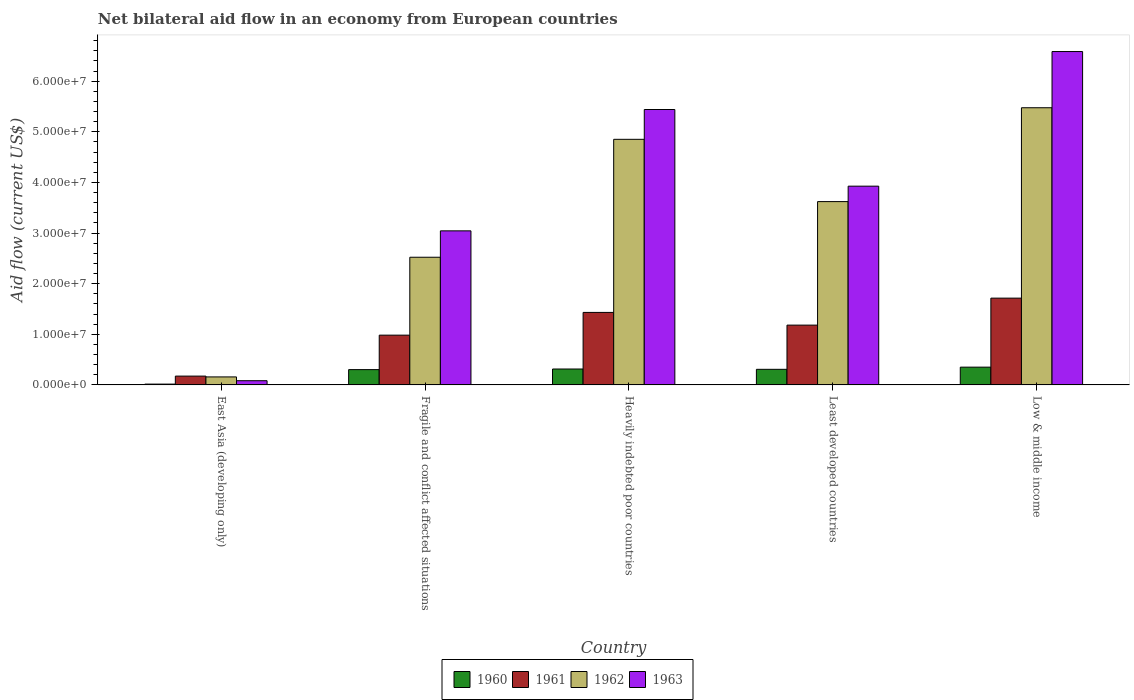How many different coloured bars are there?
Give a very brief answer. 4. How many groups of bars are there?
Your response must be concise. 5. Are the number of bars per tick equal to the number of legend labels?
Make the answer very short. Yes. What is the label of the 4th group of bars from the left?
Offer a terse response. Least developed countries. What is the net bilateral aid flow in 1962 in Least developed countries?
Make the answer very short. 3.62e+07. Across all countries, what is the maximum net bilateral aid flow in 1961?
Ensure brevity in your answer.  1.71e+07. Across all countries, what is the minimum net bilateral aid flow in 1961?
Your answer should be compact. 1.74e+06. In which country was the net bilateral aid flow in 1963 maximum?
Give a very brief answer. Low & middle income. In which country was the net bilateral aid flow in 1962 minimum?
Offer a very short reply. East Asia (developing only). What is the total net bilateral aid flow in 1963 in the graph?
Your response must be concise. 1.91e+08. What is the difference between the net bilateral aid flow in 1962 in Fragile and conflict affected situations and that in Heavily indebted poor countries?
Provide a succinct answer. -2.33e+07. What is the difference between the net bilateral aid flow in 1963 in East Asia (developing only) and the net bilateral aid flow in 1961 in Least developed countries?
Provide a succinct answer. -1.10e+07. What is the average net bilateral aid flow in 1963 per country?
Provide a short and direct response. 3.82e+07. What is the difference between the net bilateral aid flow of/in 1960 and net bilateral aid flow of/in 1963 in Least developed countries?
Provide a short and direct response. -3.62e+07. What is the ratio of the net bilateral aid flow in 1960 in Least developed countries to that in Low & middle income?
Give a very brief answer. 0.88. What is the difference between the highest and the second highest net bilateral aid flow in 1960?
Provide a succinct answer. 4.30e+05. What is the difference between the highest and the lowest net bilateral aid flow in 1962?
Ensure brevity in your answer.  5.32e+07. Is the sum of the net bilateral aid flow in 1961 in Least developed countries and Low & middle income greater than the maximum net bilateral aid flow in 1963 across all countries?
Make the answer very short. No. Is it the case that in every country, the sum of the net bilateral aid flow in 1960 and net bilateral aid flow in 1962 is greater than the sum of net bilateral aid flow in 1961 and net bilateral aid flow in 1963?
Provide a succinct answer. No. What does the 3rd bar from the left in Fragile and conflict affected situations represents?
Your answer should be very brief. 1962. How many bars are there?
Provide a short and direct response. 20. Are the values on the major ticks of Y-axis written in scientific E-notation?
Provide a short and direct response. Yes. Where does the legend appear in the graph?
Your answer should be very brief. Bottom center. What is the title of the graph?
Your response must be concise. Net bilateral aid flow in an economy from European countries. Does "2001" appear as one of the legend labels in the graph?
Offer a very short reply. No. What is the label or title of the Y-axis?
Offer a very short reply. Aid flow (current US$). What is the Aid flow (current US$) in 1961 in East Asia (developing only)?
Your answer should be compact. 1.74e+06. What is the Aid flow (current US$) of 1962 in East Asia (developing only)?
Give a very brief answer. 1.58e+06. What is the Aid flow (current US$) in 1963 in East Asia (developing only)?
Make the answer very short. 8.30e+05. What is the Aid flow (current US$) in 1960 in Fragile and conflict affected situations?
Give a very brief answer. 3.02e+06. What is the Aid flow (current US$) in 1961 in Fragile and conflict affected situations?
Give a very brief answer. 9.83e+06. What is the Aid flow (current US$) in 1962 in Fragile and conflict affected situations?
Ensure brevity in your answer.  2.52e+07. What is the Aid flow (current US$) in 1963 in Fragile and conflict affected situations?
Keep it short and to the point. 3.04e+07. What is the Aid flow (current US$) of 1960 in Heavily indebted poor countries?
Ensure brevity in your answer.  3.14e+06. What is the Aid flow (current US$) in 1961 in Heavily indebted poor countries?
Offer a terse response. 1.43e+07. What is the Aid flow (current US$) of 1962 in Heavily indebted poor countries?
Your answer should be compact. 4.85e+07. What is the Aid flow (current US$) of 1963 in Heavily indebted poor countries?
Offer a very short reply. 5.44e+07. What is the Aid flow (current US$) in 1960 in Least developed countries?
Give a very brief answer. 3.08e+06. What is the Aid flow (current US$) in 1961 in Least developed countries?
Your response must be concise. 1.18e+07. What is the Aid flow (current US$) of 1962 in Least developed countries?
Ensure brevity in your answer.  3.62e+07. What is the Aid flow (current US$) in 1963 in Least developed countries?
Ensure brevity in your answer.  3.93e+07. What is the Aid flow (current US$) in 1960 in Low & middle income?
Make the answer very short. 3.51e+06. What is the Aid flow (current US$) in 1961 in Low & middle income?
Keep it short and to the point. 1.71e+07. What is the Aid flow (current US$) in 1962 in Low & middle income?
Provide a short and direct response. 5.48e+07. What is the Aid flow (current US$) in 1963 in Low & middle income?
Make the answer very short. 6.58e+07. Across all countries, what is the maximum Aid flow (current US$) of 1960?
Provide a succinct answer. 3.51e+06. Across all countries, what is the maximum Aid flow (current US$) in 1961?
Keep it short and to the point. 1.71e+07. Across all countries, what is the maximum Aid flow (current US$) in 1962?
Your answer should be very brief. 5.48e+07. Across all countries, what is the maximum Aid flow (current US$) of 1963?
Keep it short and to the point. 6.58e+07. Across all countries, what is the minimum Aid flow (current US$) of 1961?
Provide a succinct answer. 1.74e+06. Across all countries, what is the minimum Aid flow (current US$) in 1962?
Offer a terse response. 1.58e+06. Across all countries, what is the minimum Aid flow (current US$) of 1963?
Ensure brevity in your answer.  8.30e+05. What is the total Aid flow (current US$) of 1960 in the graph?
Offer a terse response. 1.29e+07. What is the total Aid flow (current US$) in 1961 in the graph?
Your answer should be compact. 5.48e+07. What is the total Aid flow (current US$) in 1962 in the graph?
Offer a terse response. 1.66e+08. What is the total Aid flow (current US$) in 1963 in the graph?
Give a very brief answer. 1.91e+08. What is the difference between the Aid flow (current US$) in 1960 in East Asia (developing only) and that in Fragile and conflict affected situations?
Give a very brief answer. -2.86e+06. What is the difference between the Aid flow (current US$) of 1961 in East Asia (developing only) and that in Fragile and conflict affected situations?
Make the answer very short. -8.09e+06. What is the difference between the Aid flow (current US$) in 1962 in East Asia (developing only) and that in Fragile and conflict affected situations?
Keep it short and to the point. -2.36e+07. What is the difference between the Aid flow (current US$) of 1963 in East Asia (developing only) and that in Fragile and conflict affected situations?
Your response must be concise. -2.96e+07. What is the difference between the Aid flow (current US$) in 1960 in East Asia (developing only) and that in Heavily indebted poor countries?
Keep it short and to the point. -2.98e+06. What is the difference between the Aid flow (current US$) in 1961 in East Asia (developing only) and that in Heavily indebted poor countries?
Offer a terse response. -1.26e+07. What is the difference between the Aid flow (current US$) of 1962 in East Asia (developing only) and that in Heavily indebted poor countries?
Keep it short and to the point. -4.69e+07. What is the difference between the Aid flow (current US$) of 1963 in East Asia (developing only) and that in Heavily indebted poor countries?
Make the answer very short. -5.36e+07. What is the difference between the Aid flow (current US$) in 1960 in East Asia (developing only) and that in Least developed countries?
Give a very brief answer. -2.92e+06. What is the difference between the Aid flow (current US$) in 1961 in East Asia (developing only) and that in Least developed countries?
Offer a very short reply. -1.01e+07. What is the difference between the Aid flow (current US$) in 1962 in East Asia (developing only) and that in Least developed countries?
Your answer should be compact. -3.46e+07. What is the difference between the Aid flow (current US$) of 1963 in East Asia (developing only) and that in Least developed countries?
Give a very brief answer. -3.84e+07. What is the difference between the Aid flow (current US$) of 1960 in East Asia (developing only) and that in Low & middle income?
Offer a very short reply. -3.35e+06. What is the difference between the Aid flow (current US$) of 1961 in East Asia (developing only) and that in Low & middle income?
Offer a very short reply. -1.54e+07. What is the difference between the Aid flow (current US$) of 1962 in East Asia (developing only) and that in Low & middle income?
Make the answer very short. -5.32e+07. What is the difference between the Aid flow (current US$) of 1963 in East Asia (developing only) and that in Low & middle income?
Your response must be concise. -6.50e+07. What is the difference between the Aid flow (current US$) in 1960 in Fragile and conflict affected situations and that in Heavily indebted poor countries?
Provide a succinct answer. -1.20e+05. What is the difference between the Aid flow (current US$) of 1961 in Fragile and conflict affected situations and that in Heavily indebted poor countries?
Offer a very short reply. -4.49e+06. What is the difference between the Aid flow (current US$) in 1962 in Fragile and conflict affected situations and that in Heavily indebted poor countries?
Keep it short and to the point. -2.33e+07. What is the difference between the Aid flow (current US$) in 1963 in Fragile and conflict affected situations and that in Heavily indebted poor countries?
Provide a short and direct response. -2.40e+07. What is the difference between the Aid flow (current US$) in 1961 in Fragile and conflict affected situations and that in Least developed countries?
Ensure brevity in your answer.  -1.98e+06. What is the difference between the Aid flow (current US$) in 1962 in Fragile and conflict affected situations and that in Least developed countries?
Offer a very short reply. -1.10e+07. What is the difference between the Aid flow (current US$) in 1963 in Fragile and conflict affected situations and that in Least developed countries?
Offer a very short reply. -8.83e+06. What is the difference between the Aid flow (current US$) in 1960 in Fragile and conflict affected situations and that in Low & middle income?
Ensure brevity in your answer.  -4.90e+05. What is the difference between the Aid flow (current US$) in 1961 in Fragile and conflict affected situations and that in Low & middle income?
Your answer should be very brief. -7.31e+06. What is the difference between the Aid flow (current US$) in 1962 in Fragile and conflict affected situations and that in Low & middle income?
Give a very brief answer. -2.95e+07. What is the difference between the Aid flow (current US$) in 1963 in Fragile and conflict affected situations and that in Low & middle income?
Your answer should be compact. -3.54e+07. What is the difference between the Aid flow (current US$) in 1961 in Heavily indebted poor countries and that in Least developed countries?
Your response must be concise. 2.51e+06. What is the difference between the Aid flow (current US$) of 1962 in Heavily indebted poor countries and that in Least developed countries?
Your response must be concise. 1.23e+07. What is the difference between the Aid flow (current US$) of 1963 in Heavily indebted poor countries and that in Least developed countries?
Provide a short and direct response. 1.51e+07. What is the difference between the Aid flow (current US$) of 1960 in Heavily indebted poor countries and that in Low & middle income?
Give a very brief answer. -3.70e+05. What is the difference between the Aid flow (current US$) in 1961 in Heavily indebted poor countries and that in Low & middle income?
Your answer should be compact. -2.82e+06. What is the difference between the Aid flow (current US$) of 1962 in Heavily indebted poor countries and that in Low & middle income?
Your answer should be very brief. -6.24e+06. What is the difference between the Aid flow (current US$) in 1963 in Heavily indebted poor countries and that in Low & middle income?
Your answer should be compact. -1.14e+07. What is the difference between the Aid flow (current US$) of 1960 in Least developed countries and that in Low & middle income?
Give a very brief answer. -4.30e+05. What is the difference between the Aid flow (current US$) in 1961 in Least developed countries and that in Low & middle income?
Provide a succinct answer. -5.33e+06. What is the difference between the Aid flow (current US$) in 1962 in Least developed countries and that in Low & middle income?
Provide a short and direct response. -1.85e+07. What is the difference between the Aid flow (current US$) of 1963 in Least developed countries and that in Low & middle income?
Make the answer very short. -2.66e+07. What is the difference between the Aid flow (current US$) of 1960 in East Asia (developing only) and the Aid flow (current US$) of 1961 in Fragile and conflict affected situations?
Provide a short and direct response. -9.67e+06. What is the difference between the Aid flow (current US$) of 1960 in East Asia (developing only) and the Aid flow (current US$) of 1962 in Fragile and conflict affected situations?
Keep it short and to the point. -2.51e+07. What is the difference between the Aid flow (current US$) of 1960 in East Asia (developing only) and the Aid flow (current US$) of 1963 in Fragile and conflict affected situations?
Provide a short and direct response. -3.03e+07. What is the difference between the Aid flow (current US$) of 1961 in East Asia (developing only) and the Aid flow (current US$) of 1962 in Fragile and conflict affected situations?
Provide a short and direct response. -2.35e+07. What is the difference between the Aid flow (current US$) of 1961 in East Asia (developing only) and the Aid flow (current US$) of 1963 in Fragile and conflict affected situations?
Provide a short and direct response. -2.87e+07. What is the difference between the Aid flow (current US$) of 1962 in East Asia (developing only) and the Aid flow (current US$) of 1963 in Fragile and conflict affected situations?
Offer a very short reply. -2.88e+07. What is the difference between the Aid flow (current US$) in 1960 in East Asia (developing only) and the Aid flow (current US$) in 1961 in Heavily indebted poor countries?
Give a very brief answer. -1.42e+07. What is the difference between the Aid flow (current US$) of 1960 in East Asia (developing only) and the Aid flow (current US$) of 1962 in Heavily indebted poor countries?
Keep it short and to the point. -4.84e+07. What is the difference between the Aid flow (current US$) of 1960 in East Asia (developing only) and the Aid flow (current US$) of 1963 in Heavily indebted poor countries?
Provide a succinct answer. -5.42e+07. What is the difference between the Aid flow (current US$) in 1961 in East Asia (developing only) and the Aid flow (current US$) in 1962 in Heavily indebted poor countries?
Offer a very short reply. -4.68e+07. What is the difference between the Aid flow (current US$) in 1961 in East Asia (developing only) and the Aid flow (current US$) in 1963 in Heavily indebted poor countries?
Give a very brief answer. -5.27e+07. What is the difference between the Aid flow (current US$) of 1962 in East Asia (developing only) and the Aid flow (current US$) of 1963 in Heavily indebted poor countries?
Your response must be concise. -5.28e+07. What is the difference between the Aid flow (current US$) of 1960 in East Asia (developing only) and the Aid flow (current US$) of 1961 in Least developed countries?
Offer a very short reply. -1.16e+07. What is the difference between the Aid flow (current US$) of 1960 in East Asia (developing only) and the Aid flow (current US$) of 1962 in Least developed countries?
Offer a very short reply. -3.60e+07. What is the difference between the Aid flow (current US$) in 1960 in East Asia (developing only) and the Aid flow (current US$) in 1963 in Least developed countries?
Offer a terse response. -3.91e+07. What is the difference between the Aid flow (current US$) in 1961 in East Asia (developing only) and the Aid flow (current US$) in 1962 in Least developed countries?
Ensure brevity in your answer.  -3.45e+07. What is the difference between the Aid flow (current US$) in 1961 in East Asia (developing only) and the Aid flow (current US$) in 1963 in Least developed countries?
Your answer should be compact. -3.75e+07. What is the difference between the Aid flow (current US$) in 1962 in East Asia (developing only) and the Aid flow (current US$) in 1963 in Least developed countries?
Your answer should be compact. -3.77e+07. What is the difference between the Aid flow (current US$) in 1960 in East Asia (developing only) and the Aid flow (current US$) in 1961 in Low & middle income?
Your response must be concise. -1.70e+07. What is the difference between the Aid flow (current US$) of 1960 in East Asia (developing only) and the Aid flow (current US$) of 1962 in Low & middle income?
Offer a terse response. -5.46e+07. What is the difference between the Aid flow (current US$) of 1960 in East Asia (developing only) and the Aid flow (current US$) of 1963 in Low & middle income?
Give a very brief answer. -6.57e+07. What is the difference between the Aid flow (current US$) in 1961 in East Asia (developing only) and the Aid flow (current US$) in 1962 in Low & middle income?
Provide a short and direct response. -5.30e+07. What is the difference between the Aid flow (current US$) in 1961 in East Asia (developing only) and the Aid flow (current US$) in 1963 in Low & middle income?
Keep it short and to the point. -6.41e+07. What is the difference between the Aid flow (current US$) in 1962 in East Asia (developing only) and the Aid flow (current US$) in 1963 in Low & middle income?
Offer a very short reply. -6.43e+07. What is the difference between the Aid flow (current US$) of 1960 in Fragile and conflict affected situations and the Aid flow (current US$) of 1961 in Heavily indebted poor countries?
Your response must be concise. -1.13e+07. What is the difference between the Aid flow (current US$) of 1960 in Fragile and conflict affected situations and the Aid flow (current US$) of 1962 in Heavily indebted poor countries?
Make the answer very short. -4.55e+07. What is the difference between the Aid flow (current US$) in 1960 in Fragile and conflict affected situations and the Aid flow (current US$) in 1963 in Heavily indebted poor countries?
Give a very brief answer. -5.14e+07. What is the difference between the Aid flow (current US$) in 1961 in Fragile and conflict affected situations and the Aid flow (current US$) in 1962 in Heavily indebted poor countries?
Ensure brevity in your answer.  -3.87e+07. What is the difference between the Aid flow (current US$) in 1961 in Fragile and conflict affected situations and the Aid flow (current US$) in 1963 in Heavily indebted poor countries?
Provide a succinct answer. -4.46e+07. What is the difference between the Aid flow (current US$) in 1962 in Fragile and conflict affected situations and the Aid flow (current US$) in 1963 in Heavily indebted poor countries?
Offer a terse response. -2.92e+07. What is the difference between the Aid flow (current US$) of 1960 in Fragile and conflict affected situations and the Aid flow (current US$) of 1961 in Least developed countries?
Make the answer very short. -8.79e+06. What is the difference between the Aid flow (current US$) in 1960 in Fragile and conflict affected situations and the Aid flow (current US$) in 1962 in Least developed countries?
Your response must be concise. -3.32e+07. What is the difference between the Aid flow (current US$) of 1960 in Fragile and conflict affected situations and the Aid flow (current US$) of 1963 in Least developed countries?
Your answer should be compact. -3.62e+07. What is the difference between the Aid flow (current US$) of 1961 in Fragile and conflict affected situations and the Aid flow (current US$) of 1962 in Least developed countries?
Provide a succinct answer. -2.64e+07. What is the difference between the Aid flow (current US$) of 1961 in Fragile and conflict affected situations and the Aid flow (current US$) of 1963 in Least developed countries?
Offer a terse response. -2.94e+07. What is the difference between the Aid flow (current US$) of 1962 in Fragile and conflict affected situations and the Aid flow (current US$) of 1963 in Least developed countries?
Make the answer very short. -1.40e+07. What is the difference between the Aid flow (current US$) of 1960 in Fragile and conflict affected situations and the Aid flow (current US$) of 1961 in Low & middle income?
Give a very brief answer. -1.41e+07. What is the difference between the Aid flow (current US$) in 1960 in Fragile and conflict affected situations and the Aid flow (current US$) in 1962 in Low & middle income?
Make the answer very short. -5.17e+07. What is the difference between the Aid flow (current US$) in 1960 in Fragile and conflict affected situations and the Aid flow (current US$) in 1963 in Low & middle income?
Make the answer very short. -6.28e+07. What is the difference between the Aid flow (current US$) in 1961 in Fragile and conflict affected situations and the Aid flow (current US$) in 1962 in Low & middle income?
Ensure brevity in your answer.  -4.49e+07. What is the difference between the Aid flow (current US$) in 1961 in Fragile and conflict affected situations and the Aid flow (current US$) in 1963 in Low & middle income?
Your answer should be compact. -5.60e+07. What is the difference between the Aid flow (current US$) of 1962 in Fragile and conflict affected situations and the Aid flow (current US$) of 1963 in Low & middle income?
Keep it short and to the point. -4.06e+07. What is the difference between the Aid flow (current US$) of 1960 in Heavily indebted poor countries and the Aid flow (current US$) of 1961 in Least developed countries?
Give a very brief answer. -8.67e+06. What is the difference between the Aid flow (current US$) of 1960 in Heavily indebted poor countries and the Aid flow (current US$) of 1962 in Least developed countries?
Your response must be concise. -3.31e+07. What is the difference between the Aid flow (current US$) of 1960 in Heavily indebted poor countries and the Aid flow (current US$) of 1963 in Least developed countries?
Provide a succinct answer. -3.61e+07. What is the difference between the Aid flow (current US$) in 1961 in Heavily indebted poor countries and the Aid flow (current US$) in 1962 in Least developed countries?
Give a very brief answer. -2.19e+07. What is the difference between the Aid flow (current US$) in 1961 in Heavily indebted poor countries and the Aid flow (current US$) in 1963 in Least developed countries?
Ensure brevity in your answer.  -2.49e+07. What is the difference between the Aid flow (current US$) in 1962 in Heavily indebted poor countries and the Aid flow (current US$) in 1963 in Least developed countries?
Offer a terse response. 9.25e+06. What is the difference between the Aid flow (current US$) in 1960 in Heavily indebted poor countries and the Aid flow (current US$) in 1961 in Low & middle income?
Ensure brevity in your answer.  -1.40e+07. What is the difference between the Aid flow (current US$) of 1960 in Heavily indebted poor countries and the Aid flow (current US$) of 1962 in Low & middle income?
Make the answer very short. -5.16e+07. What is the difference between the Aid flow (current US$) of 1960 in Heavily indebted poor countries and the Aid flow (current US$) of 1963 in Low & middle income?
Your answer should be compact. -6.27e+07. What is the difference between the Aid flow (current US$) in 1961 in Heavily indebted poor countries and the Aid flow (current US$) in 1962 in Low & middle income?
Offer a terse response. -4.04e+07. What is the difference between the Aid flow (current US$) of 1961 in Heavily indebted poor countries and the Aid flow (current US$) of 1963 in Low & middle income?
Offer a very short reply. -5.15e+07. What is the difference between the Aid flow (current US$) in 1962 in Heavily indebted poor countries and the Aid flow (current US$) in 1963 in Low & middle income?
Your response must be concise. -1.73e+07. What is the difference between the Aid flow (current US$) in 1960 in Least developed countries and the Aid flow (current US$) in 1961 in Low & middle income?
Give a very brief answer. -1.41e+07. What is the difference between the Aid flow (current US$) in 1960 in Least developed countries and the Aid flow (current US$) in 1962 in Low & middle income?
Keep it short and to the point. -5.17e+07. What is the difference between the Aid flow (current US$) of 1960 in Least developed countries and the Aid flow (current US$) of 1963 in Low & middle income?
Offer a very short reply. -6.28e+07. What is the difference between the Aid flow (current US$) of 1961 in Least developed countries and the Aid flow (current US$) of 1962 in Low & middle income?
Your answer should be very brief. -4.29e+07. What is the difference between the Aid flow (current US$) in 1961 in Least developed countries and the Aid flow (current US$) in 1963 in Low & middle income?
Ensure brevity in your answer.  -5.40e+07. What is the difference between the Aid flow (current US$) of 1962 in Least developed countries and the Aid flow (current US$) of 1963 in Low & middle income?
Keep it short and to the point. -2.96e+07. What is the average Aid flow (current US$) of 1960 per country?
Keep it short and to the point. 2.58e+06. What is the average Aid flow (current US$) in 1961 per country?
Give a very brief answer. 1.10e+07. What is the average Aid flow (current US$) in 1962 per country?
Offer a very short reply. 3.33e+07. What is the average Aid flow (current US$) in 1963 per country?
Provide a succinct answer. 3.82e+07. What is the difference between the Aid flow (current US$) of 1960 and Aid flow (current US$) of 1961 in East Asia (developing only)?
Your answer should be compact. -1.58e+06. What is the difference between the Aid flow (current US$) of 1960 and Aid flow (current US$) of 1962 in East Asia (developing only)?
Provide a succinct answer. -1.42e+06. What is the difference between the Aid flow (current US$) of 1960 and Aid flow (current US$) of 1963 in East Asia (developing only)?
Provide a succinct answer. -6.70e+05. What is the difference between the Aid flow (current US$) of 1961 and Aid flow (current US$) of 1962 in East Asia (developing only)?
Provide a short and direct response. 1.60e+05. What is the difference between the Aid flow (current US$) in 1961 and Aid flow (current US$) in 1963 in East Asia (developing only)?
Your response must be concise. 9.10e+05. What is the difference between the Aid flow (current US$) in 1962 and Aid flow (current US$) in 1963 in East Asia (developing only)?
Provide a succinct answer. 7.50e+05. What is the difference between the Aid flow (current US$) of 1960 and Aid flow (current US$) of 1961 in Fragile and conflict affected situations?
Make the answer very short. -6.81e+06. What is the difference between the Aid flow (current US$) of 1960 and Aid flow (current US$) of 1962 in Fragile and conflict affected situations?
Give a very brief answer. -2.22e+07. What is the difference between the Aid flow (current US$) in 1960 and Aid flow (current US$) in 1963 in Fragile and conflict affected situations?
Give a very brief answer. -2.74e+07. What is the difference between the Aid flow (current US$) of 1961 and Aid flow (current US$) of 1962 in Fragile and conflict affected situations?
Your answer should be very brief. -1.54e+07. What is the difference between the Aid flow (current US$) in 1961 and Aid flow (current US$) in 1963 in Fragile and conflict affected situations?
Give a very brief answer. -2.06e+07. What is the difference between the Aid flow (current US$) of 1962 and Aid flow (current US$) of 1963 in Fragile and conflict affected situations?
Provide a short and direct response. -5.21e+06. What is the difference between the Aid flow (current US$) in 1960 and Aid flow (current US$) in 1961 in Heavily indebted poor countries?
Ensure brevity in your answer.  -1.12e+07. What is the difference between the Aid flow (current US$) in 1960 and Aid flow (current US$) in 1962 in Heavily indebted poor countries?
Keep it short and to the point. -4.54e+07. What is the difference between the Aid flow (current US$) of 1960 and Aid flow (current US$) of 1963 in Heavily indebted poor countries?
Your answer should be very brief. -5.13e+07. What is the difference between the Aid flow (current US$) of 1961 and Aid flow (current US$) of 1962 in Heavily indebted poor countries?
Provide a short and direct response. -3.42e+07. What is the difference between the Aid flow (current US$) in 1961 and Aid flow (current US$) in 1963 in Heavily indebted poor countries?
Provide a succinct answer. -4.01e+07. What is the difference between the Aid flow (current US$) in 1962 and Aid flow (current US$) in 1963 in Heavily indebted poor countries?
Give a very brief answer. -5.89e+06. What is the difference between the Aid flow (current US$) in 1960 and Aid flow (current US$) in 1961 in Least developed countries?
Make the answer very short. -8.73e+06. What is the difference between the Aid flow (current US$) in 1960 and Aid flow (current US$) in 1962 in Least developed countries?
Provide a short and direct response. -3.31e+07. What is the difference between the Aid flow (current US$) of 1960 and Aid flow (current US$) of 1963 in Least developed countries?
Provide a succinct answer. -3.62e+07. What is the difference between the Aid flow (current US$) in 1961 and Aid flow (current US$) in 1962 in Least developed countries?
Offer a very short reply. -2.44e+07. What is the difference between the Aid flow (current US$) of 1961 and Aid flow (current US$) of 1963 in Least developed countries?
Your response must be concise. -2.74e+07. What is the difference between the Aid flow (current US$) in 1962 and Aid flow (current US$) in 1963 in Least developed countries?
Give a very brief answer. -3.05e+06. What is the difference between the Aid flow (current US$) of 1960 and Aid flow (current US$) of 1961 in Low & middle income?
Provide a short and direct response. -1.36e+07. What is the difference between the Aid flow (current US$) of 1960 and Aid flow (current US$) of 1962 in Low & middle income?
Provide a short and direct response. -5.12e+07. What is the difference between the Aid flow (current US$) in 1960 and Aid flow (current US$) in 1963 in Low & middle income?
Provide a succinct answer. -6.23e+07. What is the difference between the Aid flow (current US$) of 1961 and Aid flow (current US$) of 1962 in Low & middle income?
Provide a succinct answer. -3.76e+07. What is the difference between the Aid flow (current US$) in 1961 and Aid flow (current US$) in 1963 in Low & middle income?
Keep it short and to the point. -4.87e+07. What is the difference between the Aid flow (current US$) in 1962 and Aid flow (current US$) in 1963 in Low & middle income?
Your answer should be very brief. -1.11e+07. What is the ratio of the Aid flow (current US$) of 1960 in East Asia (developing only) to that in Fragile and conflict affected situations?
Make the answer very short. 0.05. What is the ratio of the Aid flow (current US$) of 1961 in East Asia (developing only) to that in Fragile and conflict affected situations?
Offer a very short reply. 0.18. What is the ratio of the Aid flow (current US$) in 1962 in East Asia (developing only) to that in Fragile and conflict affected situations?
Give a very brief answer. 0.06. What is the ratio of the Aid flow (current US$) of 1963 in East Asia (developing only) to that in Fragile and conflict affected situations?
Your answer should be compact. 0.03. What is the ratio of the Aid flow (current US$) in 1960 in East Asia (developing only) to that in Heavily indebted poor countries?
Provide a short and direct response. 0.05. What is the ratio of the Aid flow (current US$) of 1961 in East Asia (developing only) to that in Heavily indebted poor countries?
Ensure brevity in your answer.  0.12. What is the ratio of the Aid flow (current US$) in 1962 in East Asia (developing only) to that in Heavily indebted poor countries?
Ensure brevity in your answer.  0.03. What is the ratio of the Aid flow (current US$) of 1963 in East Asia (developing only) to that in Heavily indebted poor countries?
Keep it short and to the point. 0.02. What is the ratio of the Aid flow (current US$) of 1960 in East Asia (developing only) to that in Least developed countries?
Ensure brevity in your answer.  0.05. What is the ratio of the Aid flow (current US$) in 1961 in East Asia (developing only) to that in Least developed countries?
Keep it short and to the point. 0.15. What is the ratio of the Aid flow (current US$) in 1962 in East Asia (developing only) to that in Least developed countries?
Provide a succinct answer. 0.04. What is the ratio of the Aid flow (current US$) in 1963 in East Asia (developing only) to that in Least developed countries?
Keep it short and to the point. 0.02. What is the ratio of the Aid flow (current US$) of 1960 in East Asia (developing only) to that in Low & middle income?
Give a very brief answer. 0.05. What is the ratio of the Aid flow (current US$) of 1961 in East Asia (developing only) to that in Low & middle income?
Offer a terse response. 0.1. What is the ratio of the Aid flow (current US$) in 1962 in East Asia (developing only) to that in Low & middle income?
Provide a short and direct response. 0.03. What is the ratio of the Aid flow (current US$) of 1963 in East Asia (developing only) to that in Low & middle income?
Ensure brevity in your answer.  0.01. What is the ratio of the Aid flow (current US$) in 1960 in Fragile and conflict affected situations to that in Heavily indebted poor countries?
Provide a succinct answer. 0.96. What is the ratio of the Aid flow (current US$) in 1961 in Fragile and conflict affected situations to that in Heavily indebted poor countries?
Your answer should be very brief. 0.69. What is the ratio of the Aid flow (current US$) in 1962 in Fragile and conflict affected situations to that in Heavily indebted poor countries?
Your answer should be very brief. 0.52. What is the ratio of the Aid flow (current US$) of 1963 in Fragile and conflict affected situations to that in Heavily indebted poor countries?
Make the answer very short. 0.56. What is the ratio of the Aid flow (current US$) in 1960 in Fragile and conflict affected situations to that in Least developed countries?
Give a very brief answer. 0.98. What is the ratio of the Aid flow (current US$) in 1961 in Fragile and conflict affected situations to that in Least developed countries?
Provide a succinct answer. 0.83. What is the ratio of the Aid flow (current US$) in 1962 in Fragile and conflict affected situations to that in Least developed countries?
Make the answer very short. 0.7. What is the ratio of the Aid flow (current US$) of 1963 in Fragile and conflict affected situations to that in Least developed countries?
Your response must be concise. 0.78. What is the ratio of the Aid flow (current US$) in 1960 in Fragile and conflict affected situations to that in Low & middle income?
Offer a terse response. 0.86. What is the ratio of the Aid flow (current US$) in 1961 in Fragile and conflict affected situations to that in Low & middle income?
Your response must be concise. 0.57. What is the ratio of the Aid flow (current US$) in 1962 in Fragile and conflict affected situations to that in Low & middle income?
Offer a terse response. 0.46. What is the ratio of the Aid flow (current US$) in 1963 in Fragile and conflict affected situations to that in Low & middle income?
Give a very brief answer. 0.46. What is the ratio of the Aid flow (current US$) of 1960 in Heavily indebted poor countries to that in Least developed countries?
Your answer should be compact. 1.02. What is the ratio of the Aid flow (current US$) of 1961 in Heavily indebted poor countries to that in Least developed countries?
Your answer should be compact. 1.21. What is the ratio of the Aid flow (current US$) of 1962 in Heavily indebted poor countries to that in Least developed countries?
Your response must be concise. 1.34. What is the ratio of the Aid flow (current US$) of 1963 in Heavily indebted poor countries to that in Least developed countries?
Keep it short and to the point. 1.39. What is the ratio of the Aid flow (current US$) of 1960 in Heavily indebted poor countries to that in Low & middle income?
Provide a succinct answer. 0.89. What is the ratio of the Aid flow (current US$) of 1961 in Heavily indebted poor countries to that in Low & middle income?
Your answer should be very brief. 0.84. What is the ratio of the Aid flow (current US$) in 1962 in Heavily indebted poor countries to that in Low & middle income?
Your answer should be compact. 0.89. What is the ratio of the Aid flow (current US$) in 1963 in Heavily indebted poor countries to that in Low & middle income?
Ensure brevity in your answer.  0.83. What is the ratio of the Aid flow (current US$) of 1960 in Least developed countries to that in Low & middle income?
Give a very brief answer. 0.88. What is the ratio of the Aid flow (current US$) in 1961 in Least developed countries to that in Low & middle income?
Ensure brevity in your answer.  0.69. What is the ratio of the Aid flow (current US$) in 1962 in Least developed countries to that in Low & middle income?
Keep it short and to the point. 0.66. What is the ratio of the Aid flow (current US$) of 1963 in Least developed countries to that in Low & middle income?
Your response must be concise. 0.6. What is the difference between the highest and the second highest Aid flow (current US$) in 1961?
Ensure brevity in your answer.  2.82e+06. What is the difference between the highest and the second highest Aid flow (current US$) of 1962?
Provide a succinct answer. 6.24e+06. What is the difference between the highest and the second highest Aid flow (current US$) in 1963?
Provide a short and direct response. 1.14e+07. What is the difference between the highest and the lowest Aid flow (current US$) of 1960?
Your answer should be compact. 3.35e+06. What is the difference between the highest and the lowest Aid flow (current US$) of 1961?
Provide a succinct answer. 1.54e+07. What is the difference between the highest and the lowest Aid flow (current US$) in 1962?
Ensure brevity in your answer.  5.32e+07. What is the difference between the highest and the lowest Aid flow (current US$) of 1963?
Your answer should be compact. 6.50e+07. 